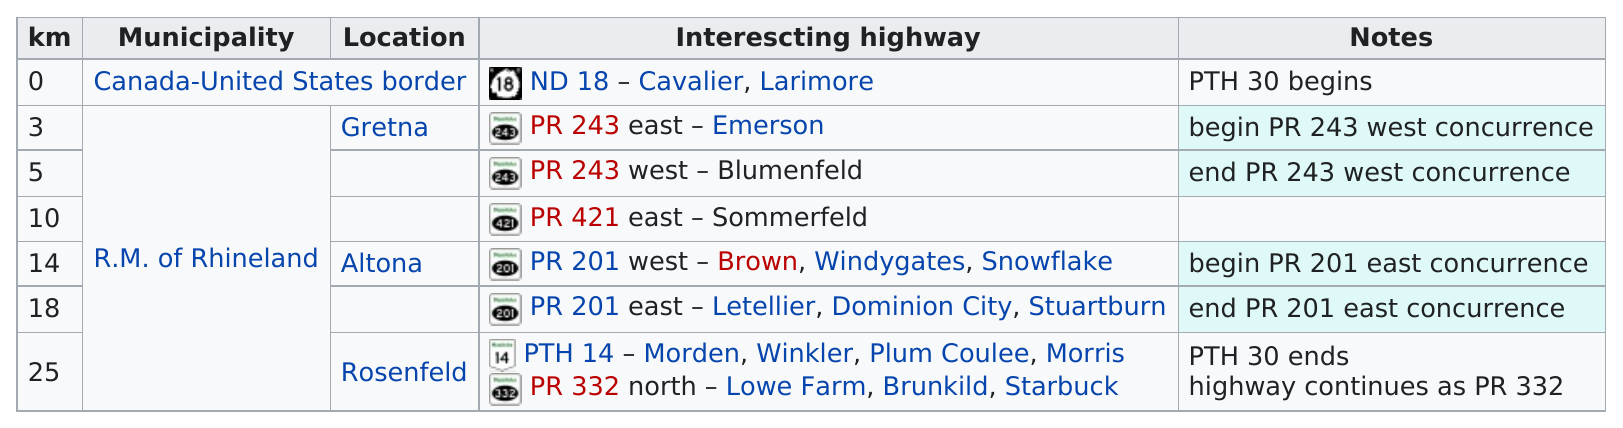Mention a couple of crucial points in this snapshot. The first town that is intersecting with Highway 243 heading east is Emerson. Eighteen cities are represented in the category of intersecting highways. The total distance of all municipalities is 75 kilometers. The total of location is 4. The location of the highway is larger at Rosenfeld. 